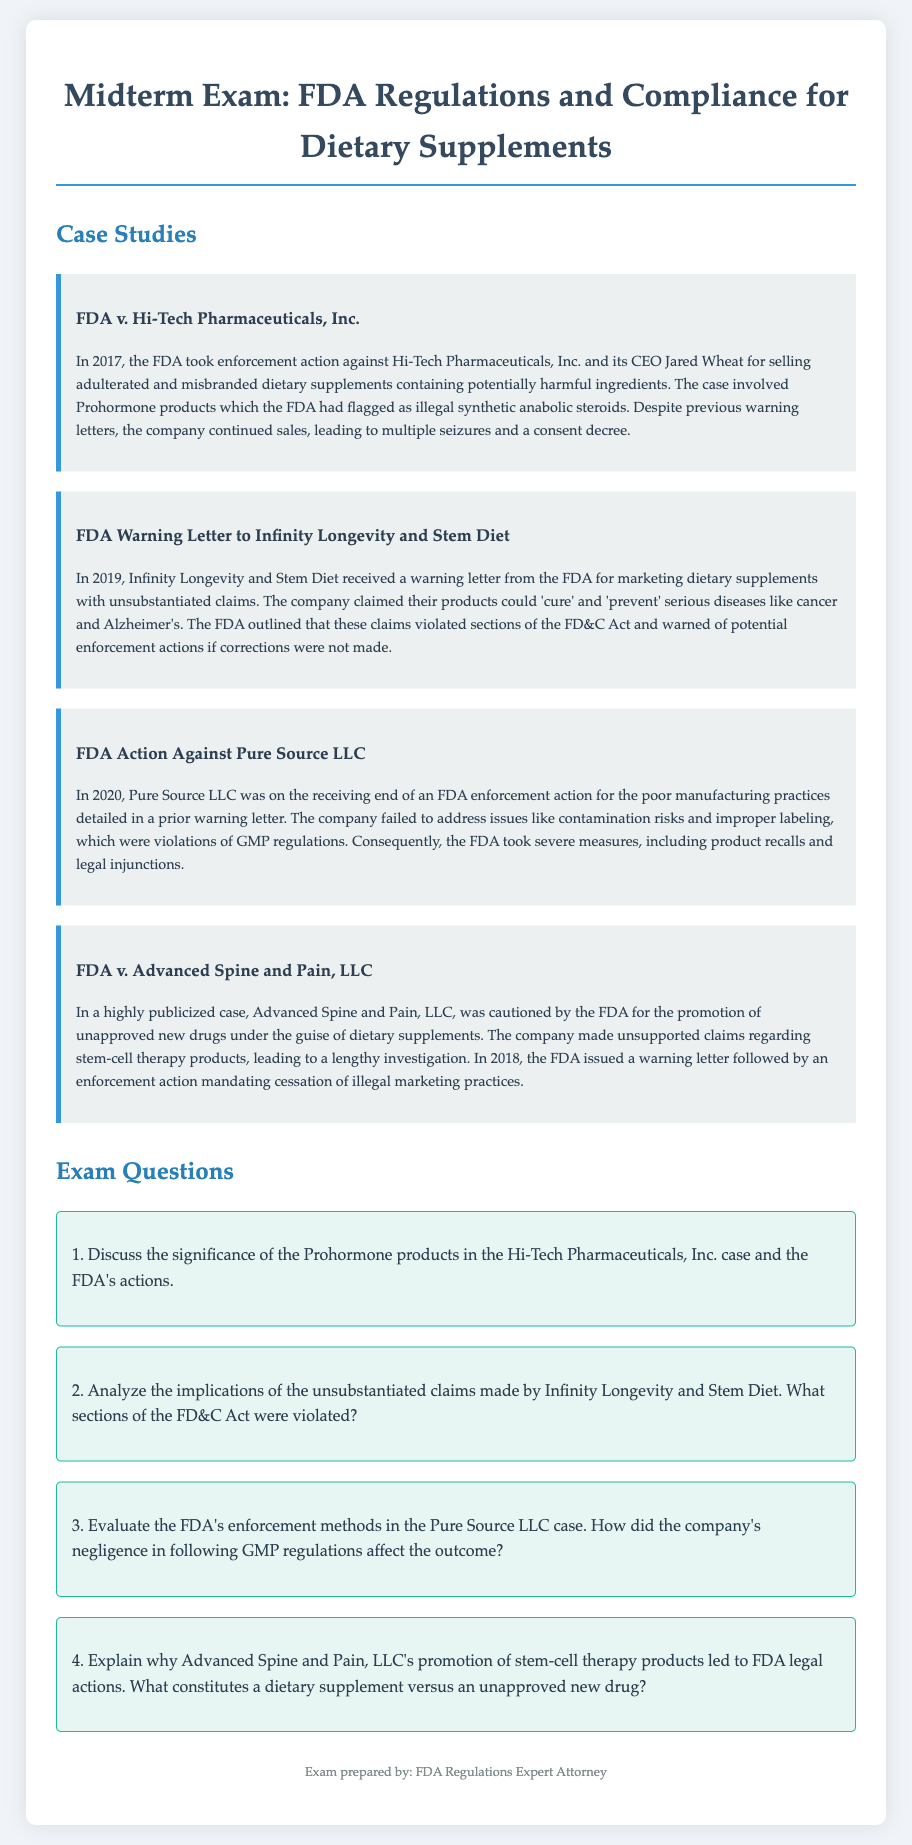What company received a warning letter for marketing unsubstantiated claims in 2019? The warning letter was sent to Infinity Longevity and Stem Diet in 2019.
Answer: Infinity Longevity and Stem Diet What type of regulatory violation did Pure Source LLC commit? Pure Source LLC was cited for poor manufacturing practices violating GMP regulations.
Answer: GMP regulations What legal action did the FDA impose on Advanced Spine and Pain, LLC regarding their product marketing? The FDA issued a warning letter followed by an enforcement action mandating cessation of illegal marketing practices.
Answer: Cessation of illegal marketing practices Why did the FDA take action against Pure Source LLC? The FDA took action because Pure Source LLC failed to address contamination risks and improper labeling, as mentioned in a prior warning letter.
Answer: Contamination risks and improper labeling 